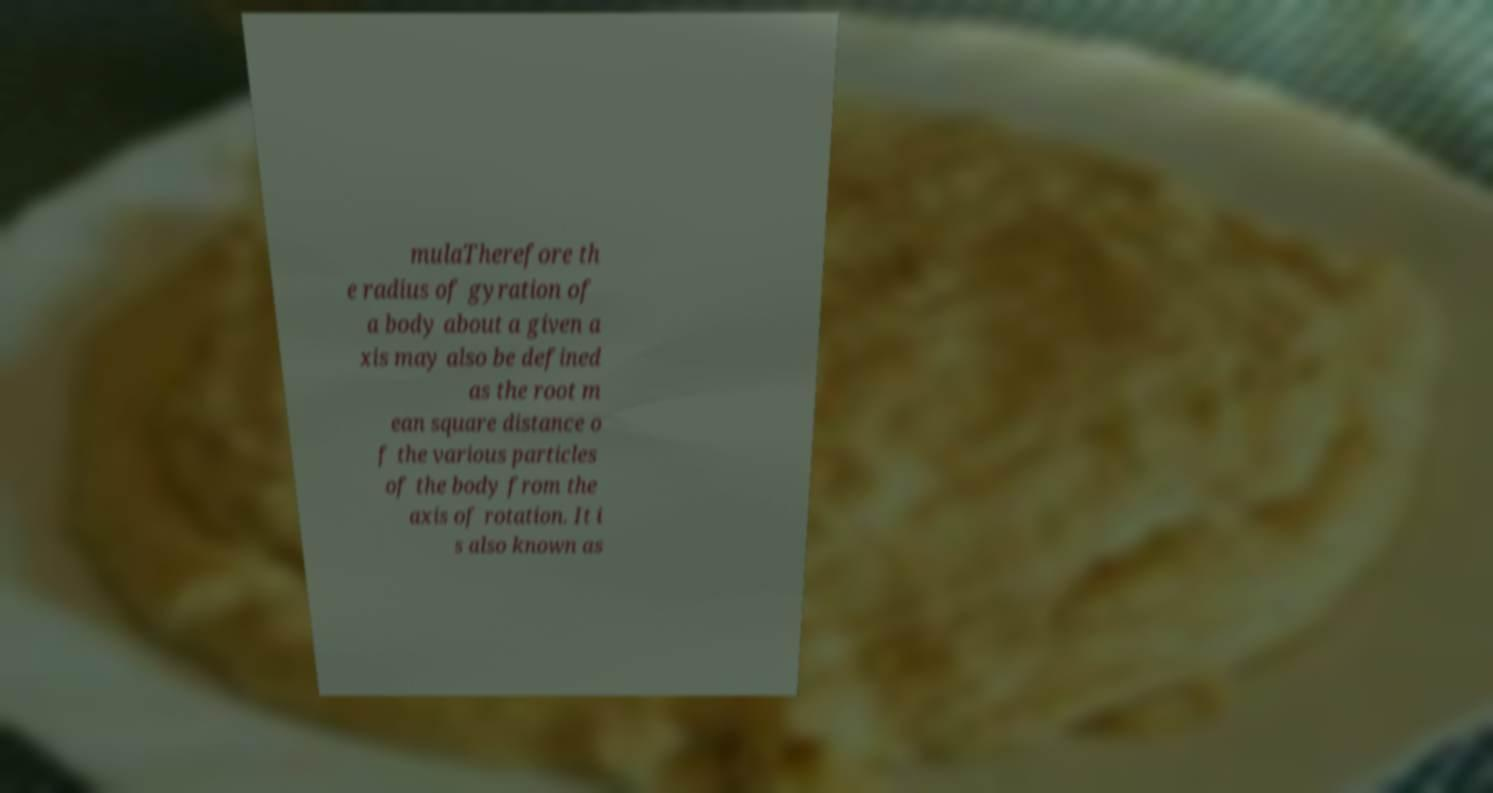Can you accurately transcribe the text from the provided image for me? mulaTherefore th e radius of gyration of a body about a given a xis may also be defined as the root m ean square distance o f the various particles of the body from the axis of rotation. It i s also known as 